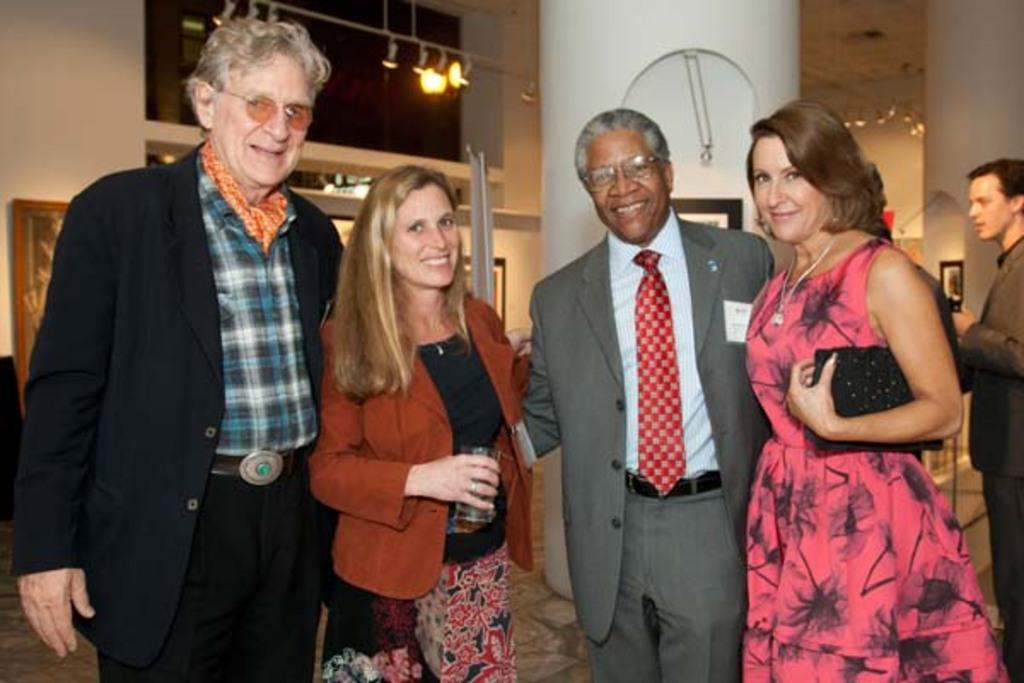What can be observed about the people in the image? There are people standing in the image. What material is present in the image that is transparent? There is glass visible in the image. What type of illumination is present in the image? There are lights in the image. What vertical structure can be seen in the image? There is a pole in the image. What type of rice is being served at the airport in the image? There is no airport or rice present in the image. 